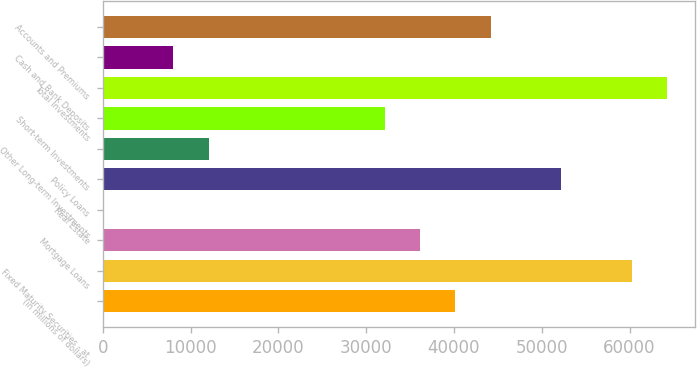Convert chart to OTSL. <chart><loc_0><loc_0><loc_500><loc_500><bar_chart><fcel>(in millions of dollars)<fcel>Fixed Maturity Securities - at<fcel>Mortgage Loans<fcel>Real Estate<fcel>Policy Loans<fcel>Other Long-term Investments<fcel>Short-term Investments<fcel>Total Investments<fcel>Cash and Bank Deposits<fcel>Accounts and Premiums<nl><fcel>40163.3<fcel>60236<fcel>36148.8<fcel>17.9<fcel>52206.9<fcel>12061.5<fcel>32134.2<fcel>64250.5<fcel>8046.98<fcel>44177.8<nl></chart> 